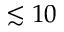Convert formula to latex. <formula><loc_0><loc_0><loc_500><loc_500>\lesssim 1 0</formula> 